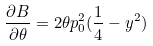Convert formula to latex. <formula><loc_0><loc_0><loc_500><loc_500>\frac { \partial B } { \partial \theta } = 2 \theta p _ { 0 } ^ { 2 } ( \frac { 1 } { 4 } - y ^ { 2 } )</formula> 